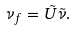Convert formula to latex. <formula><loc_0><loc_0><loc_500><loc_500>\nu _ { f } = \tilde { U } \tilde { \nu } .</formula> 